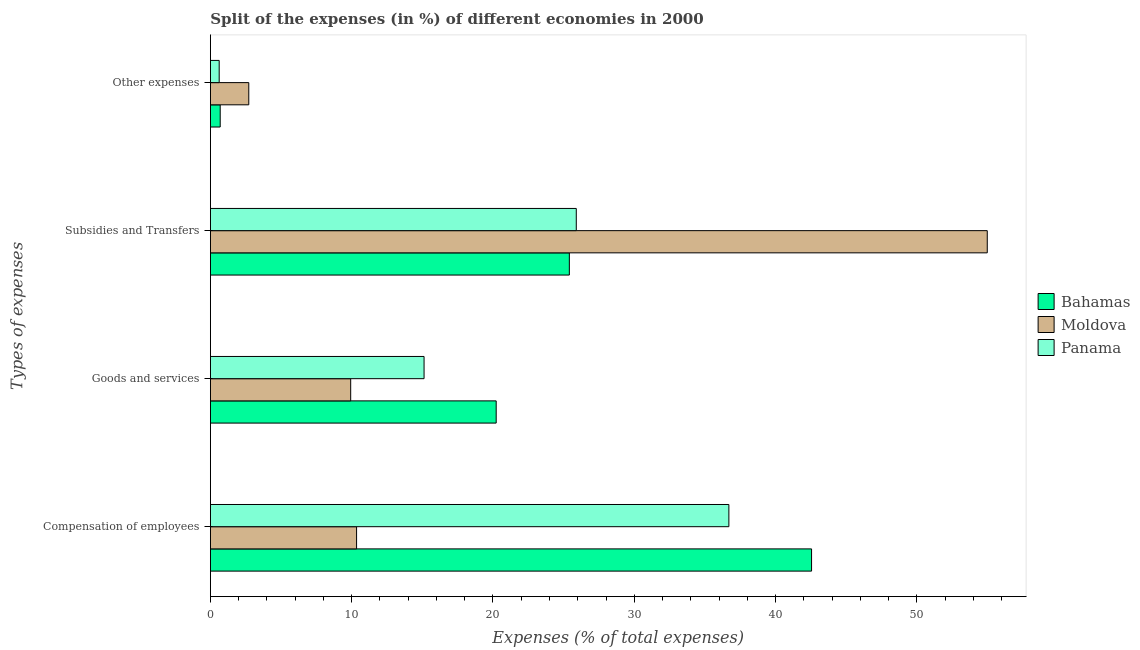Are the number of bars on each tick of the Y-axis equal?
Make the answer very short. Yes. What is the label of the 2nd group of bars from the top?
Ensure brevity in your answer.  Subsidies and Transfers. What is the percentage of amount spent on subsidies in Panama?
Provide a succinct answer. 25.89. Across all countries, what is the maximum percentage of amount spent on compensation of employees?
Your answer should be compact. 42.55. Across all countries, what is the minimum percentage of amount spent on goods and services?
Give a very brief answer. 9.93. In which country was the percentage of amount spent on goods and services maximum?
Your answer should be compact. Bahamas. In which country was the percentage of amount spent on subsidies minimum?
Ensure brevity in your answer.  Bahamas. What is the total percentage of amount spent on compensation of employees in the graph?
Offer a very short reply. 89.59. What is the difference between the percentage of amount spent on compensation of employees in Moldova and that in Panama?
Provide a succinct answer. -26.35. What is the difference between the percentage of amount spent on subsidies in Moldova and the percentage of amount spent on compensation of employees in Bahamas?
Your response must be concise. 12.43. What is the average percentage of amount spent on goods and services per country?
Ensure brevity in your answer.  15.09. What is the difference between the percentage of amount spent on subsidies and percentage of amount spent on goods and services in Bahamas?
Offer a very short reply. 5.18. What is the ratio of the percentage of amount spent on subsidies in Bahamas to that in Moldova?
Make the answer very short. 0.46. What is the difference between the highest and the second highest percentage of amount spent on compensation of employees?
Provide a short and direct response. 5.85. What is the difference between the highest and the lowest percentage of amount spent on compensation of employees?
Make the answer very short. 32.2. What does the 3rd bar from the top in Goods and services represents?
Your answer should be compact. Bahamas. What does the 2nd bar from the bottom in Compensation of employees represents?
Keep it short and to the point. Moldova. What is the difference between two consecutive major ticks on the X-axis?
Provide a short and direct response. 10. Are the values on the major ticks of X-axis written in scientific E-notation?
Give a very brief answer. No. How are the legend labels stacked?
Your answer should be very brief. Vertical. What is the title of the graph?
Your response must be concise. Split of the expenses (in %) of different economies in 2000. What is the label or title of the X-axis?
Offer a very short reply. Expenses (% of total expenses). What is the label or title of the Y-axis?
Make the answer very short. Types of expenses. What is the Expenses (% of total expenses) in Bahamas in Compensation of employees?
Your response must be concise. 42.55. What is the Expenses (% of total expenses) in Moldova in Compensation of employees?
Ensure brevity in your answer.  10.35. What is the Expenses (% of total expenses) in Panama in Compensation of employees?
Offer a very short reply. 36.69. What is the Expenses (% of total expenses) in Bahamas in Goods and services?
Give a very brief answer. 20.23. What is the Expenses (% of total expenses) of Moldova in Goods and services?
Ensure brevity in your answer.  9.93. What is the Expenses (% of total expenses) in Panama in Goods and services?
Provide a short and direct response. 15.12. What is the Expenses (% of total expenses) of Bahamas in Subsidies and Transfers?
Provide a short and direct response. 25.4. What is the Expenses (% of total expenses) in Moldova in Subsidies and Transfers?
Provide a succinct answer. 54.98. What is the Expenses (% of total expenses) of Panama in Subsidies and Transfers?
Provide a short and direct response. 25.89. What is the Expenses (% of total expenses) in Bahamas in Other expenses?
Ensure brevity in your answer.  0.7. What is the Expenses (% of total expenses) in Moldova in Other expenses?
Provide a short and direct response. 2.72. What is the Expenses (% of total expenses) of Panama in Other expenses?
Offer a very short reply. 0.62. Across all Types of expenses, what is the maximum Expenses (% of total expenses) of Bahamas?
Provide a short and direct response. 42.55. Across all Types of expenses, what is the maximum Expenses (% of total expenses) in Moldova?
Provide a short and direct response. 54.98. Across all Types of expenses, what is the maximum Expenses (% of total expenses) of Panama?
Your answer should be compact. 36.69. Across all Types of expenses, what is the minimum Expenses (% of total expenses) in Bahamas?
Provide a succinct answer. 0.7. Across all Types of expenses, what is the minimum Expenses (% of total expenses) in Moldova?
Make the answer very short. 2.72. Across all Types of expenses, what is the minimum Expenses (% of total expenses) in Panama?
Your response must be concise. 0.62. What is the total Expenses (% of total expenses) in Bahamas in the graph?
Your answer should be very brief. 88.87. What is the total Expenses (% of total expenses) in Moldova in the graph?
Give a very brief answer. 77.97. What is the total Expenses (% of total expenses) in Panama in the graph?
Your answer should be very brief. 78.33. What is the difference between the Expenses (% of total expenses) of Bahamas in Compensation of employees and that in Goods and services?
Give a very brief answer. 22.32. What is the difference between the Expenses (% of total expenses) in Moldova in Compensation of employees and that in Goods and services?
Your response must be concise. 0.42. What is the difference between the Expenses (% of total expenses) of Panama in Compensation of employees and that in Goods and services?
Make the answer very short. 21.57. What is the difference between the Expenses (% of total expenses) in Bahamas in Compensation of employees and that in Subsidies and Transfers?
Provide a short and direct response. 17.14. What is the difference between the Expenses (% of total expenses) of Moldova in Compensation of employees and that in Subsidies and Transfers?
Provide a short and direct response. -44.63. What is the difference between the Expenses (% of total expenses) in Panama in Compensation of employees and that in Subsidies and Transfers?
Your answer should be compact. 10.8. What is the difference between the Expenses (% of total expenses) in Bahamas in Compensation of employees and that in Other expenses?
Give a very brief answer. 41.85. What is the difference between the Expenses (% of total expenses) in Moldova in Compensation of employees and that in Other expenses?
Provide a short and direct response. 7.63. What is the difference between the Expenses (% of total expenses) of Panama in Compensation of employees and that in Other expenses?
Make the answer very short. 36.07. What is the difference between the Expenses (% of total expenses) of Bahamas in Goods and services and that in Subsidies and Transfers?
Offer a very short reply. -5.18. What is the difference between the Expenses (% of total expenses) in Moldova in Goods and services and that in Subsidies and Transfers?
Offer a terse response. -45.05. What is the difference between the Expenses (% of total expenses) of Panama in Goods and services and that in Subsidies and Transfers?
Give a very brief answer. -10.77. What is the difference between the Expenses (% of total expenses) of Bahamas in Goods and services and that in Other expenses?
Give a very brief answer. 19.53. What is the difference between the Expenses (% of total expenses) in Moldova in Goods and services and that in Other expenses?
Your answer should be compact. 7.21. What is the difference between the Expenses (% of total expenses) in Panama in Goods and services and that in Other expenses?
Give a very brief answer. 14.5. What is the difference between the Expenses (% of total expenses) in Bahamas in Subsidies and Transfers and that in Other expenses?
Offer a terse response. 24.71. What is the difference between the Expenses (% of total expenses) in Moldova in Subsidies and Transfers and that in Other expenses?
Your answer should be compact. 52.26. What is the difference between the Expenses (% of total expenses) of Panama in Subsidies and Transfers and that in Other expenses?
Make the answer very short. 25.27. What is the difference between the Expenses (% of total expenses) of Bahamas in Compensation of employees and the Expenses (% of total expenses) of Moldova in Goods and services?
Give a very brief answer. 32.62. What is the difference between the Expenses (% of total expenses) in Bahamas in Compensation of employees and the Expenses (% of total expenses) in Panama in Goods and services?
Offer a very short reply. 27.42. What is the difference between the Expenses (% of total expenses) in Moldova in Compensation of employees and the Expenses (% of total expenses) in Panama in Goods and services?
Your response must be concise. -4.78. What is the difference between the Expenses (% of total expenses) of Bahamas in Compensation of employees and the Expenses (% of total expenses) of Moldova in Subsidies and Transfers?
Provide a succinct answer. -12.43. What is the difference between the Expenses (% of total expenses) in Bahamas in Compensation of employees and the Expenses (% of total expenses) in Panama in Subsidies and Transfers?
Keep it short and to the point. 16.65. What is the difference between the Expenses (% of total expenses) of Moldova in Compensation of employees and the Expenses (% of total expenses) of Panama in Subsidies and Transfers?
Provide a short and direct response. -15.55. What is the difference between the Expenses (% of total expenses) of Bahamas in Compensation of employees and the Expenses (% of total expenses) of Moldova in Other expenses?
Offer a terse response. 39.83. What is the difference between the Expenses (% of total expenses) of Bahamas in Compensation of employees and the Expenses (% of total expenses) of Panama in Other expenses?
Your response must be concise. 41.92. What is the difference between the Expenses (% of total expenses) of Moldova in Compensation of employees and the Expenses (% of total expenses) of Panama in Other expenses?
Offer a terse response. 9.72. What is the difference between the Expenses (% of total expenses) in Bahamas in Goods and services and the Expenses (% of total expenses) in Moldova in Subsidies and Transfers?
Your answer should be very brief. -34.75. What is the difference between the Expenses (% of total expenses) in Bahamas in Goods and services and the Expenses (% of total expenses) in Panama in Subsidies and Transfers?
Offer a very short reply. -5.67. What is the difference between the Expenses (% of total expenses) of Moldova in Goods and services and the Expenses (% of total expenses) of Panama in Subsidies and Transfers?
Keep it short and to the point. -15.97. What is the difference between the Expenses (% of total expenses) in Bahamas in Goods and services and the Expenses (% of total expenses) in Moldova in Other expenses?
Keep it short and to the point. 17.51. What is the difference between the Expenses (% of total expenses) of Bahamas in Goods and services and the Expenses (% of total expenses) of Panama in Other expenses?
Your answer should be compact. 19.6. What is the difference between the Expenses (% of total expenses) in Moldova in Goods and services and the Expenses (% of total expenses) in Panama in Other expenses?
Offer a terse response. 9.31. What is the difference between the Expenses (% of total expenses) in Bahamas in Subsidies and Transfers and the Expenses (% of total expenses) in Moldova in Other expenses?
Keep it short and to the point. 22.69. What is the difference between the Expenses (% of total expenses) in Bahamas in Subsidies and Transfers and the Expenses (% of total expenses) in Panama in Other expenses?
Your answer should be compact. 24.78. What is the difference between the Expenses (% of total expenses) in Moldova in Subsidies and Transfers and the Expenses (% of total expenses) in Panama in Other expenses?
Give a very brief answer. 54.36. What is the average Expenses (% of total expenses) of Bahamas per Types of expenses?
Keep it short and to the point. 22.22. What is the average Expenses (% of total expenses) in Moldova per Types of expenses?
Provide a short and direct response. 19.49. What is the average Expenses (% of total expenses) in Panama per Types of expenses?
Give a very brief answer. 19.58. What is the difference between the Expenses (% of total expenses) in Bahamas and Expenses (% of total expenses) in Moldova in Compensation of employees?
Offer a very short reply. 32.2. What is the difference between the Expenses (% of total expenses) of Bahamas and Expenses (% of total expenses) of Panama in Compensation of employees?
Keep it short and to the point. 5.85. What is the difference between the Expenses (% of total expenses) in Moldova and Expenses (% of total expenses) in Panama in Compensation of employees?
Your response must be concise. -26.35. What is the difference between the Expenses (% of total expenses) in Bahamas and Expenses (% of total expenses) in Moldova in Goods and services?
Ensure brevity in your answer.  10.3. What is the difference between the Expenses (% of total expenses) of Bahamas and Expenses (% of total expenses) of Panama in Goods and services?
Keep it short and to the point. 5.1. What is the difference between the Expenses (% of total expenses) of Moldova and Expenses (% of total expenses) of Panama in Goods and services?
Ensure brevity in your answer.  -5.19. What is the difference between the Expenses (% of total expenses) of Bahamas and Expenses (% of total expenses) of Moldova in Subsidies and Transfers?
Provide a short and direct response. -29.58. What is the difference between the Expenses (% of total expenses) in Bahamas and Expenses (% of total expenses) in Panama in Subsidies and Transfers?
Give a very brief answer. -0.49. What is the difference between the Expenses (% of total expenses) of Moldova and Expenses (% of total expenses) of Panama in Subsidies and Transfers?
Ensure brevity in your answer.  29.09. What is the difference between the Expenses (% of total expenses) in Bahamas and Expenses (% of total expenses) in Moldova in Other expenses?
Your response must be concise. -2.02. What is the difference between the Expenses (% of total expenses) in Bahamas and Expenses (% of total expenses) in Panama in Other expenses?
Give a very brief answer. 0.07. What is the difference between the Expenses (% of total expenses) of Moldova and Expenses (% of total expenses) of Panama in Other expenses?
Your response must be concise. 2.09. What is the ratio of the Expenses (% of total expenses) of Bahamas in Compensation of employees to that in Goods and services?
Your answer should be very brief. 2.1. What is the ratio of the Expenses (% of total expenses) in Moldova in Compensation of employees to that in Goods and services?
Make the answer very short. 1.04. What is the ratio of the Expenses (% of total expenses) in Panama in Compensation of employees to that in Goods and services?
Your answer should be very brief. 2.43. What is the ratio of the Expenses (% of total expenses) in Bahamas in Compensation of employees to that in Subsidies and Transfers?
Provide a succinct answer. 1.67. What is the ratio of the Expenses (% of total expenses) of Moldova in Compensation of employees to that in Subsidies and Transfers?
Give a very brief answer. 0.19. What is the ratio of the Expenses (% of total expenses) of Panama in Compensation of employees to that in Subsidies and Transfers?
Keep it short and to the point. 1.42. What is the ratio of the Expenses (% of total expenses) in Bahamas in Compensation of employees to that in Other expenses?
Your answer should be compact. 61.21. What is the ratio of the Expenses (% of total expenses) of Moldova in Compensation of employees to that in Other expenses?
Give a very brief answer. 3.81. What is the ratio of the Expenses (% of total expenses) of Panama in Compensation of employees to that in Other expenses?
Provide a succinct answer. 58.89. What is the ratio of the Expenses (% of total expenses) in Bahamas in Goods and services to that in Subsidies and Transfers?
Keep it short and to the point. 0.8. What is the ratio of the Expenses (% of total expenses) of Moldova in Goods and services to that in Subsidies and Transfers?
Your response must be concise. 0.18. What is the ratio of the Expenses (% of total expenses) in Panama in Goods and services to that in Subsidies and Transfers?
Give a very brief answer. 0.58. What is the ratio of the Expenses (% of total expenses) in Bahamas in Goods and services to that in Other expenses?
Provide a succinct answer. 29.1. What is the ratio of the Expenses (% of total expenses) of Moldova in Goods and services to that in Other expenses?
Your response must be concise. 3.65. What is the ratio of the Expenses (% of total expenses) of Panama in Goods and services to that in Other expenses?
Provide a short and direct response. 24.27. What is the ratio of the Expenses (% of total expenses) of Bahamas in Subsidies and Transfers to that in Other expenses?
Your answer should be compact. 36.55. What is the ratio of the Expenses (% of total expenses) in Moldova in Subsidies and Transfers to that in Other expenses?
Offer a terse response. 20.24. What is the ratio of the Expenses (% of total expenses) in Panama in Subsidies and Transfers to that in Other expenses?
Offer a terse response. 41.56. What is the difference between the highest and the second highest Expenses (% of total expenses) of Bahamas?
Offer a terse response. 17.14. What is the difference between the highest and the second highest Expenses (% of total expenses) in Moldova?
Your answer should be very brief. 44.63. What is the difference between the highest and the second highest Expenses (% of total expenses) in Panama?
Make the answer very short. 10.8. What is the difference between the highest and the lowest Expenses (% of total expenses) of Bahamas?
Provide a short and direct response. 41.85. What is the difference between the highest and the lowest Expenses (% of total expenses) of Moldova?
Make the answer very short. 52.26. What is the difference between the highest and the lowest Expenses (% of total expenses) in Panama?
Provide a short and direct response. 36.07. 